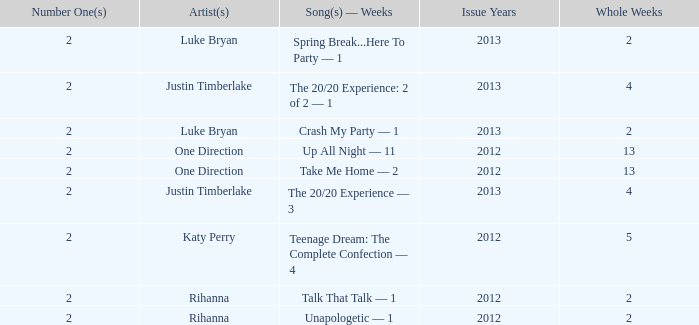What is the title of every song, and how many weeks was each song at #1 for One Direction? Up All Night — 11, Take Me Home — 2. 